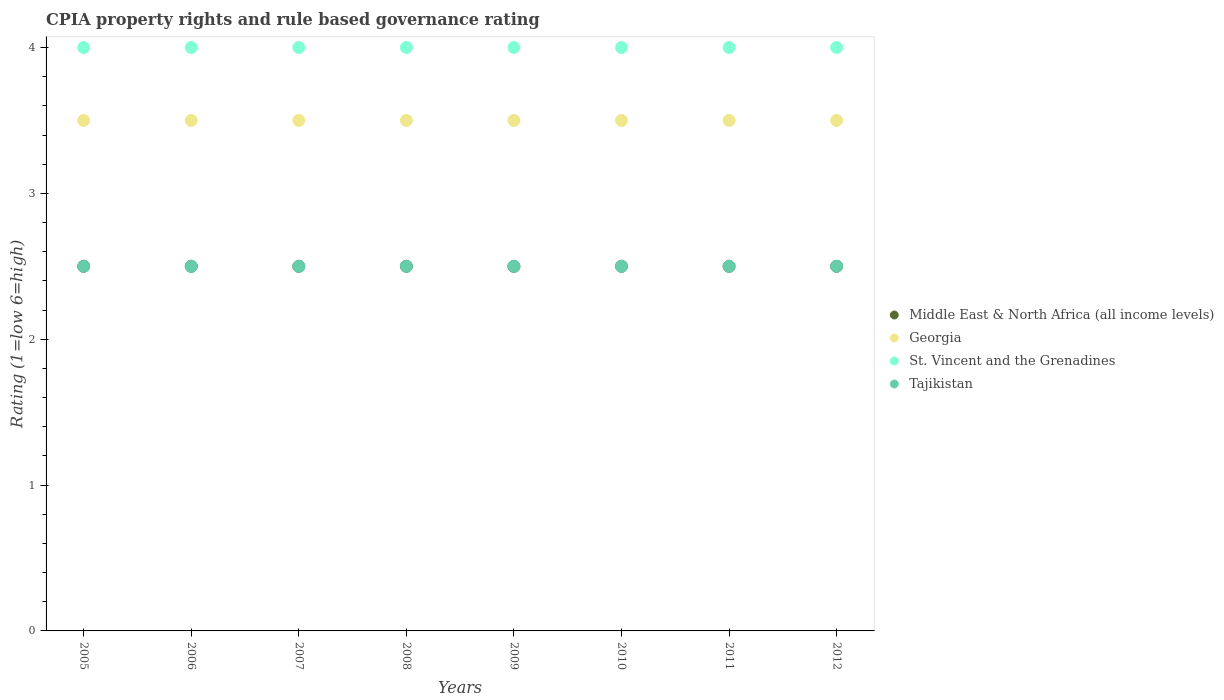Is the number of dotlines equal to the number of legend labels?
Your answer should be very brief. Yes. What is the CPIA rating in Middle East & North Africa (all income levels) in 2009?
Provide a succinct answer. 2.5. Across all years, what is the maximum CPIA rating in St. Vincent and the Grenadines?
Provide a short and direct response. 4. Across all years, what is the minimum CPIA rating in Tajikistan?
Ensure brevity in your answer.  2.5. In which year was the CPIA rating in St. Vincent and the Grenadines maximum?
Offer a terse response. 2005. In which year was the CPIA rating in Georgia minimum?
Your response must be concise. 2005. What is the difference between the CPIA rating in Middle East & North Africa (all income levels) in 2005 and that in 2009?
Provide a short and direct response. 0. What is the difference between the CPIA rating in Middle East & North Africa (all income levels) in 2006 and the CPIA rating in St. Vincent and the Grenadines in 2012?
Offer a terse response. -1.5. What is the average CPIA rating in Tajikistan per year?
Offer a very short reply. 2.5. In the year 2009, what is the difference between the CPIA rating in Middle East & North Africa (all income levels) and CPIA rating in St. Vincent and the Grenadines?
Your response must be concise. -1.5. In how many years, is the CPIA rating in Georgia greater than 3.6?
Your answer should be compact. 0. What is the ratio of the CPIA rating in St. Vincent and the Grenadines in 2005 to that in 2010?
Your answer should be very brief. 1. What is the difference between the highest and the second highest CPIA rating in St. Vincent and the Grenadines?
Give a very brief answer. 0. What is the difference between the highest and the lowest CPIA rating in Tajikistan?
Provide a succinct answer. 0. In how many years, is the CPIA rating in St. Vincent and the Grenadines greater than the average CPIA rating in St. Vincent and the Grenadines taken over all years?
Your answer should be very brief. 0. Is the CPIA rating in St. Vincent and the Grenadines strictly greater than the CPIA rating in Georgia over the years?
Ensure brevity in your answer.  Yes. Is the CPIA rating in Middle East & North Africa (all income levels) strictly less than the CPIA rating in St. Vincent and the Grenadines over the years?
Give a very brief answer. Yes. How many dotlines are there?
Provide a succinct answer. 4. What is the difference between two consecutive major ticks on the Y-axis?
Ensure brevity in your answer.  1. Does the graph contain grids?
Provide a succinct answer. No. Where does the legend appear in the graph?
Your response must be concise. Center right. How many legend labels are there?
Your response must be concise. 4. What is the title of the graph?
Make the answer very short. CPIA property rights and rule based governance rating. Does "Kyrgyz Republic" appear as one of the legend labels in the graph?
Provide a short and direct response. No. What is the label or title of the X-axis?
Offer a terse response. Years. What is the Rating (1=low 6=high) of St. Vincent and the Grenadines in 2005?
Provide a short and direct response. 4. What is the Rating (1=low 6=high) of Tajikistan in 2005?
Give a very brief answer. 2.5. What is the Rating (1=low 6=high) of Middle East & North Africa (all income levels) in 2006?
Offer a terse response. 2.5. What is the Rating (1=low 6=high) in St. Vincent and the Grenadines in 2006?
Offer a very short reply. 4. What is the Rating (1=low 6=high) in Tajikistan in 2006?
Offer a very short reply. 2.5. What is the Rating (1=low 6=high) of Georgia in 2007?
Give a very brief answer. 3.5. What is the Rating (1=low 6=high) in St. Vincent and the Grenadines in 2007?
Make the answer very short. 4. What is the Rating (1=low 6=high) of Georgia in 2008?
Ensure brevity in your answer.  3.5. What is the Rating (1=low 6=high) in Middle East & North Africa (all income levels) in 2010?
Your answer should be very brief. 2.5. What is the Rating (1=low 6=high) of Georgia in 2010?
Provide a succinct answer. 3.5. What is the Rating (1=low 6=high) in Middle East & North Africa (all income levels) in 2011?
Your answer should be compact. 2.5. What is the Rating (1=low 6=high) in Georgia in 2011?
Offer a very short reply. 3.5. What is the Rating (1=low 6=high) in Georgia in 2012?
Ensure brevity in your answer.  3.5. What is the Rating (1=low 6=high) of St. Vincent and the Grenadines in 2012?
Your response must be concise. 4. What is the Rating (1=low 6=high) of Tajikistan in 2012?
Provide a succinct answer. 2.5. Across all years, what is the maximum Rating (1=low 6=high) of Georgia?
Provide a short and direct response. 3.5. Across all years, what is the maximum Rating (1=low 6=high) of Tajikistan?
Make the answer very short. 2.5. Across all years, what is the minimum Rating (1=low 6=high) of St. Vincent and the Grenadines?
Ensure brevity in your answer.  4. What is the total Rating (1=low 6=high) in Middle East & North Africa (all income levels) in the graph?
Your response must be concise. 20. What is the total Rating (1=low 6=high) of Tajikistan in the graph?
Your answer should be very brief. 20. What is the difference between the Rating (1=low 6=high) of Georgia in 2005 and that in 2006?
Your response must be concise. 0. What is the difference between the Rating (1=low 6=high) of St. Vincent and the Grenadines in 2005 and that in 2006?
Provide a succinct answer. 0. What is the difference between the Rating (1=low 6=high) in Tajikistan in 2005 and that in 2006?
Offer a terse response. 0. What is the difference between the Rating (1=low 6=high) of Georgia in 2005 and that in 2007?
Give a very brief answer. 0. What is the difference between the Rating (1=low 6=high) of St. Vincent and the Grenadines in 2005 and that in 2007?
Your answer should be compact. 0. What is the difference between the Rating (1=low 6=high) of St. Vincent and the Grenadines in 2005 and that in 2008?
Provide a short and direct response. 0. What is the difference between the Rating (1=low 6=high) of Middle East & North Africa (all income levels) in 2005 and that in 2009?
Give a very brief answer. 0. What is the difference between the Rating (1=low 6=high) of Georgia in 2005 and that in 2009?
Offer a very short reply. 0. What is the difference between the Rating (1=low 6=high) in St. Vincent and the Grenadines in 2005 and that in 2010?
Provide a succinct answer. 0. What is the difference between the Rating (1=low 6=high) in Middle East & North Africa (all income levels) in 2005 and that in 2011?
Provide a succinct answer. 0. What is the difference between the Rating (1=low 6=high) in Georgia in 2005 and that in 2011?
Make the answer very short. 0. What is the difference between the Rating (1=low 6=high) of St. Vincent and the Grenadines in 2005 and that in 2011?
Offer a terse response. 0. What is the difference between the Rating (1=low 6=high) in Tajikistan in 2005 and that in 2011?
Your answer should be very brief. 0. What is the difference between the Rating (1=low 6=high) in Middle East & North Africa (all income levels) in 2005 and that in 2012?
Keep it short and to the point. 0. What is the difference between the Rating (1=low 6=high) in Georgia in 2005 and that in 2012?
Provide a succinct answer. 0. What is the difference between the Rating (1=low 6=high) of St. Vincent and the Grenadines in 2005 and that in 2012?
Your answer should be compact. 0. What is the difference between the Rating (1=low 6=high) of Tajikistan in 2005 and that in 2012?
Your answer should be very brief. 0. What is the difference between the Rating (1=low 6=high) in St. Vincent and the Grenadines in 2006 and that in 2007?
Your response must be concise. 0. What is the difference between the Rating (1=low 6=high) in Tajikistan in 2006 and that in 2007?
Your response must be concise. 0. What is the difference between the Rating (1=low 6=high) in Middle East & North Africa (all income levels) in 2006 and that in 2008?
Make the answer very short. 0. What is the difference between the Rating (1=low 6=high) of Georgia in 2006 and that in 2008?
Your answer should be compact. 0. What is the difference between the Rating (1=low 6=high) of St. Vincent and the Grenadines in 2006 and that in 2008?
Offer a very short reply. 0. What is the difference between the Rating (1=low 6=high) in Middle East & North Africa (all income levels) in 2006 and that in 2009?
Offer a terse response. 0. What is the difference between the Rating (1=low 6=high) of Georgia in 2006 and that in 2009?
Offer a terse response. 0. What is the difference between the Rating (1=low 6=high) of St. Vincent and the Grenadines in 2006 and that in 2009?
Offer a very short reply. 0. What is the difference between the Rating (1=low 6=high) in St. Vincent and the Grenadines in 2006 and that in 2010?
Your answer should be very brief. 0. What is the difference between the Rating (1=low 6=high) in Middle East & North Africa (all income levels) in 2006 and that in 2011?
Offer a terse response. 0. What is the difference between the Rating (1=low 6=high) of Georgia in 2006 and that in 2011?
Offer a terse response. 0. What is the difference between the Rating (1=low 6=high) of St. Vincent and the Grenadines in 2006 and that in 2011?
Your answer should be very brief. 0. What is the difference between the Rating (1=low 6=high) of Tajikistan in 2006 and that in 2011?
Ensure brevity in your answer.  0. What is the difference between the Rating (1=low 6=high) of St. Vincent and the Grenadines in 2006 and that in 2012?
Your answer should be compact. 0. What is the difference between the Rating (1=low 6=high) in Middle East & North Africa (all income levels) in 2007 and that in 2008?
Keep it short and to the point. 0. What is the difference between the Rating (1=low 6=high) of Georgia in 2007 and that in 2009?
Provide a succinct answer. 0. What is the difference between the Rating (1=low 6=high) of St. Vincent and the Grenadines in 2007 and that in 2009?
Provide a succinct answer. 0. What is the difference between the Rating (1=low 6=high) in Georgia in 2007 and that in 2010?
Offer a terse response. 0. What is the difference between the Rating (1=low 6=high) in Tajikistan in 2007 and that in 2010?
Offer a very short reply. 0. What is the difference between the Rating (1=low 6=high) of St. Vincent and the Grenadines in 2007 and that in 2011?
Give a very brief answer. 0. What is the difference between the Rating (1=low 6=high) of Georgia in 2007 and that in 2012?
Provide a short and direct response. 0. What is the difference between the Rating (1=low 6=high) of St. Vincent and the Grenadines in 2007 and that in 2012?
Ensure brevity in your answer.  0. What is the difference between the Rating (1=low 6=high) of St. Vincent and the Grenadines in 2008 and that in 2009?
Provide a short and direct response. 0. What is the difference between the Rating (1=low 6=high) of Middle East & North Africa (all income levels) in 2008 and that in 2010?
Your answer should be compact. 0. What is the difference between the Rating (1=low 6=high) of Georgia in 2008 and that in 2010?
Provide a short and direct response. 0. What is the difference between the Rating (1=low 6=high) of St. Vincent and the Grenadines in 2008 and that in 2010?
Your answer should be compact. 0. What is the difference between the Rating (1=low 6=high) of Middle East & North Africa (all income levels) in 2008 and that in 2011?
Your response must be concise. 0. What is the difference between the Rating (1=low 6=high) in Georgia in 2008 and that in 2011?
Your answer should be very brief. 0. What is the difference between the Rating (1=low 6=high) in St. Vincent and the Grenadines in 2008 and that in 2011?
Provide a short and direct response. 0. What is the difference between the Rating (1=low 6=high) in Tajikistan in 2008 and that in 2011?
Make the answer very short. 0. What is the difference between the Rating (1=low 6=high) of Georgia in 2008 and that in 2012?
Keep it short and to the point. 0. What is the difference between the Rating (1=low 6=high) in Tajikistan in 2008 and that in 2012?
Keep it short and to the point. 0. What is the difference between the Rating (1=low 6=high) in Middle East & North Africa (all income levels) in 2009 and that in 2010?
Give a very brief answer. 0. What is the difference between the Rating (1=low 6=high) in Georgia in 2009 and that in 2010?
Provide a succinct answer. 0. What is the difference between the Rating (1=low 6=high) in St. Vincent and the Grenadines in 2009 and that in 2010?
Keep it short and to the point. 0. What is the difference between the Rating (1=low 6=high) of St. Vincent and the Grenadines in 2009 and that in 2011?
Your answer should be very brief. 0. What is the difference between the Rating (1=low 6=high) of Middle East & North Africa (all income levels) in 2009 and that in 2012?
Ensure brevity in your answer.  0. What is the difference between the Rating (1=low 6=high) in Tajikistan in 2009 and that in 2012?
Your response must be concise. 0. What is the difference between the Rating (1=low 6=high) of Middle East & North Africa (all income levels) in 2010 and that in 2011?
Your answer should be very brief. 0. What is the difference between the Rating (1=low 6=high) in Georgia in 2010 and that in 2011?
Your answer should be compact. 0. What is the difference between the Rating (1=low 6=high) in Middle East & North Africa (all income levels) in 2010 and that in 2012?
Provide a short and direct response. 0. What is the difference between the Rating (1=low 6=high) in Georgia in 2010 and that in 2012?
Your answer should be very brief. 0. What is the difference between the Rating (1=low 6=high) in Middle East & North Africa (all income levels) in 2011 and that in 2012?
Ensure brevity in your answer.  0. What is the difference between the Rating (1=low 6=high) of Tajikistan in 2011 and that in 2012?
Your answer should be compact. 0. What is the difference between the Rating (1=low 6=high) of Middle East & North Africa (all income levels) in 2005 and the Rating (1=low 6=high) of St. Vincent and the Grenadines in 2006?
Keep it short and to the point. -1.5. What is the difference between the Rating (1=low 6=high) of Middle East & North Africa (all income levels) in 2005 and the Rating (1=low 6=high) of Tajikistan in 2006?
Provide a short and direct response. 0. What is the difference between the Rating (1=low 6=high) of Georgia in 2005 and the Rating (1=low 6=high) of St. Vincent and the Grenadines in 2006?
Provide a succinct answer. -0.5. What is the difference between the Rating (1=low 6=high) of St. Vincent and the Grenadines in 2005 and the Rating (1=low 6=high) of Tajikistan in 2006?
Your answer should be very brief. 1.5. What is the difference between the Rating (1=low 6=high) of Middle East & North Africa (all income levels) in 2005 and the Rating (1=low 6=high) of Georgia in 2007?
Your answer should be very brief. -1. What is the difference between the Rating (1=low 6=high) in Middle East & North Africa (all income levels) in 2005 and the Rating (1=low 6=high) in St. Vincent and the Grenadines in 2007?
Provide a short and direct response. -1.5. What is the difference between the Rating (1=low 6=high) in Middle East & North Africa (all income levels) in 2005 and the Rating (1=low 6=high) in Tajikistan in 2008?
Your response must be concise. 0. What is the difference between the Rating (1=low 6=high) of Georgia in 2005 and the Rating (1=low 6=high) of St. Vincent and the Grenadines in 2008?
Your answer should be very brief. -0.5. What is the difference between the Rating (1=low 6=high) of Middle East & North Africa (all income levels) in 2005 and the Rating (1=low 6=high) of Georgia in 2009?
Your response must be concise. -1. What is the difference between the Rating (1=low 6=high) of Middle East & North Africa (all income levels) in 2005 and the Rating (1=low 6=high) of St. Vincent and the Grenadines in 2009?
Your response must be concise. -1.5. What is the difference between the Rating (1=low 6=high) of Georgia in 2005 and the Rating (1=low 6=high) of Tajikistan in 2009?
Your response must be concise. 1. What is the difference between the Rating (1=low 6=high) of Middle East & North Africa (all income levels) in 2005 and the Rating (1=low 6=high) of Georgia in 2010?
Offer a terse response. -1. What is the difference between the Rating (1=low 6=high) of Georgia in 2005 and the Rating (1=low 6=high) of St. Vincent and the Grenadines in 2010?
Provide a succinct answer. -0.5. What is the difference between the Rating (1=low 6=high) in Georgia in 2005 and the Rating (1=low 6=high) in Tajikistan in 2010?
Keep it short and to the point. 1. What is the difference between the Rating (1=low 6=high) in St. Vincent and the Grenadines in 2005 and the Rating (1=low 6=high) in Tajikistan in 2010?
Offer a very short reply. 1.5. What is the difference between the Rating (1=low 6=high) of Middle East & North Africa (all income levels) in 2005 and the Rating (1=low 6=high) of Georgia in 2011?
Offer a very short reply. -1. What is the difference between the Rating (1=low 6=high) in Middle East & North Africa (all income levels) in 2005 and the Rating (1=low 6=high) in Tajikistan in 2011?
Your answer should be compact. 0. What is the difference between the Rating (1=low 6=high) in Georgia in 2005 and the Rating (1=low 6=high) in Tajikistan in 2011?
Your answer should be very brief. 1. What is the difference between the Rating (1=low 6=high) of Middle East & North Africa (all income levels) in 2005 and the Rating (1=low 6=high) of Georgia in 2012?
Make the answer very short. -1. What is the difference between the Rating (1=low 6=high) of Middle East & North Africa (all income levels) in 2005 and the Rating (1=low 6=high) of Tajikistan in 2012?
Provide a short and direct response. 0. What is the difference between the Rating (1=low 6=high) in Georgia in 2005 and the Rating (1=low 6=high) in St. Vincent and the Grenadines in 2012?
Keep it short and to the point. -0.5. What is the difference between the Rating (1=low 6=high) of St. Vincent and the Grenadines in 2005 and the Rating (1=low 6=high) of Tajikistan in 2012?
Ensure brevity in your answer.  1.5. What is the difference between the Rating (1=low 6=high) of Middle East & North Africa (all income levels) in 2006 and the Rating (1=low 6=high) of St. Vincent and the Grenadines in 2007?
Make the answer very short. -1.5. What is the difference between the Rating (1=low 6=high) of Georgia in 2006 and the Rating (1=low 6=high) of Tajikistan in 2007?
Ensure brevity in your answer.  1. What is the difference between the Rating (1=low 6=high) in St. Vincent and the Grenadines in 2006 and the Rating (1=low 6=high) in Tajikistan in 2007?
Keep it short and to the point. 1.5. What is the difference between the Rating (1=low 6=high) of Middle East & North Africa (all income levels) in 2006 and the Rating (1=low 6=high) of St. Vincent and the Grenadines in 2008?
Keep it short and to the point. -1.5. What is the difference between the Rating (1=low 6=high) in Georgia in 2006 and the Rating (1=low 6=high) in St. Vincent and the Grenadines in 2008?
Provide a succinct answer. -0.5. What is the difference between the Rating (1=low 6=high) of Georgia in 2006 and the Rating (1=low 6=high) of St. Vincent and the Grenadines in 2009?
Make the answer very short. -0.5. What is the difference between the Rating (1=low 6=high) of Middle East & North Africa (all income levels) in 2006 and the Rating (1=low 6=high) of Georgia in 2010?
Keep it short and to the point. -1. What is the difference between the Rating (1=low 6=high) in Middle East & North Africa (all income levels) in 2006 and the Rating (1=low 6=high) in Tajikistan in 2011?
Offer a terse response. 0. What is the difference between the Rating (1=low 6=high) in Georgia in 2006 and the Rating (1=low 6=high) in St. Vincent and the Grenadines in 2011?
Offer a very short reply. -0.5. What is the difference between the Rating (1=low 6=high) in Middle East & North Africa (all income levels) in 2006 and the Rating (1=low 6=high) in Georgia in 2012?
Your answer should be very brief. -1. What is the difference between the Rating (1=low 6=high) in Georgia in 2006 and the Rating (1=low 6=high) in St. Vincent and the Grenadines in 2012?
Keep it short and to the point. -0.5. What is the difference between the Rating (1=low 6=high) of Georgia in 2006 and the Rating (1=low 6=high) of Tajikistan in 2012?
Your response must be concise. 1. What is the difference between the Rating (1=low 6=high) of St. Vincent and the Grenadines in 2006 and the Rating (1=low 6=high) of Tajikistan in 2012?
Keep it short and to the point. 1.5. What is the difference between the Rating (1=low 6=high) of Middle East & North Africa (all income levels) in 2007 and the Rating (1=low 6=high) of Georgia in 2008?
Offer a terse response. -1. What is the difference between the Rating (1=low 6=high) in Middle East & North Africa (all income levels) in 2007 and the Rating (1=low 6=high) in St. Vincent and the Grenadines in 2008?
Provide a succinct answer. -1.5. What is the difference between the Rating (1=low 6=high) in Middle East & North Africa (all income levels) in 2007 and the Rating (1=low 6=high) in Tajikistan in 2008?
Your answer should be very brief. 0. What is the difference between the Rating (1=low 6=high) of Georgia in 2007 and the Rating (1=low 6=high) of St. Vincent and the Grenadines in 2008?
Give a very brief answer. -0.5. What is the difference between the Rating (1=low 6=high) in St. Vincent and the Grenadines in 2007 and the Rating (1=low 6=high) in Tajikistan in 2008?
Provide a succinct answer. 1.5. What is the difference between the Rating (1=low 6=high) in Middle East & North Africa (all income levels) in 2007 and the Rating (1=low 6=high) in Georgia in 2009?
Keep it short and to the point. -1. What is the difference between the Rating (1=low 6=high) in Middle East & North Africa (all income levels) in 2007 and the Rating (1=low 6=high) in St. Vincent and the Grenadines in 2009?
Offer a very short reply. -1.5. What is the difference between the Rating (1=low 6=high) in Georgia in 2007 and the Rating (1=low 6=high) in Tajikistan in 2009?
Provide a short and direct response. 1. What is the difference between the Rating (1=low 6=high) of Middle East & North Africa (all income levels) in 2007 and the Rating (1=low 6=high) of St. Vincent and the Grenadines in 2010?
Offer a very short reply. -1.5. What is the difference between the Rating (1=low 6=high) of Middle East & North Africa (all income levels) in 2007 and the Rating (1=low 6=high) of Tajikistan in 2010?
Provide a succinct answer. 0. What is the difference between the Rating (1=low 6=high) of St. Vincent and the Grenadines in 2007 and the Rating (1=low 6=high) of Tajikistan in 2010?
Make the answer very short. 1.5. What is the difference between the Rating (1=low 6=high) of Middle East & North Africa (all income levels) in 2007 and the Rating (1=low 6=high) of Georgia in 2011?
Provide a short and direct response. -1. What is the difference between the Rating (1=low 6=high) in Middle East & North Africa (all income levels) in 2007 and the Rating (1=low 6=high) in Tajikistan in 2011?
Provide a succinct answer. 0. What is the difference between the Rating (1=low 6=high) of St. Vincent and the Grenadines in 2007 and the Rating (1=low 6=high) of Tajikistan in 2011?
Your response must be concise. 1.5. What is the difference between the Rating (1=low 6=high) of Middle East & North Africa (all income levels) in 2007 and the Rating (1=low 6=high) of Georgia in 2012?
Offer a very short reply. -1. What is the difference between the Rating (1=low 6=high) of Georgia in 2007 and the Rating (1=low 6=high) of Tajikistan in 2012?
Ensure brevity in your answer.  1. What is the difference between the Rating (1=low 6=high) of St. Vincent and the Grenadines in 2007 and the Rating (1=low 6=high) of Tajikistan in 2012?
Keep it short and to the point. 1.5. What is the difference between the Rating (1=low 6=high) in Middle East & North Africa (all income levels) in 2008 and the Rating (1=low 6=high) in Georgia in 2009?
Provide a short and direct response. -1. What is the difference between the Rating (1=low 6=high) of Middle East & North Africa (all income levels) in 2008 and the Rating (1=low 6=high) of St. Vincent and the Grenadines in 2010?
Provide a short and direct response. -1.5. What is the difference between the Rating (1=low 6=high) of Middle East & North Africa (all income levels) in 2008 and the Rating (1=low 6=high) of Tajikistan in 2010?
Ensure brevity in your answer.  0. What is the difference between the Rating (1=low 6=high) of Georgia in 2008 and the Rating (1=low 6=high) of St. Vincent and the Grenadines in 2010?
Provide a succinct answer. -0.5. What is the difference between the Rating (1=low 6=high) in St. Vincent and the Grenadines in 2008 and the Rating (1=low 6=high) in Tajikistan in 2010?
Your answer should be compact. 1.5. What is the difference between the Rating (1=low 6=high) of Middle East & North Africa (all income levels) in 2008 and the Rating (1=low 6=high) of St. Vincent and the Grenadines in 2011?
Ensure brevity in your answer.  -1.5. What is the difference between the Rating (1=low 6=high) of Georgia in 2008 and the Rating (1=low 6=high) of St. Vincent and the Grenadines in 2011?
Ensure brevity in your answer.  -0.5. What is the difference between the Rating (1=low 6=high) in Georgia in 2008 and the Rating (1=low 6=high) in Tajikistan in 2011?
Make the answer very short. 1. What is the difference between the Rating (1=low 6=high) of Middle East & North Africa (all income levels) in 2008 and the Rating (1=low 6=high) of Georgia in 2012?
Your response must be concise. -1. What is the difference between the Rating (1=low 6=high) in Georgia in 2008 and the Rating (1=low 6=high) in St. Vincent and the Grenadines in 2012?
Keep it short and to the point. -0.5. What is the difference between the Rating (1=low 6=high) in Georgia in 2008 and the Rating (1=low 6=high) in Tajikistan in 2012?
Give a very brief answer. 1. What is the difference between the Rating (1=low 6=high) in St. Vincent and the Grenadines in 2008 and the Rating (1=low 6=high) in Tajikistan in 2012?
Provide a succinct answer. 1.5. What is the difference between the Rating (1=low 6=high) of Middle East & North Africa (all income levels) in 2009 and the Rating (1=low 6=high) of Tajikistan in 2010?
Give a very brief answer. 0. What is the difference between the Rating (1=low 6=high) in Georgia in 2009 and the Rating (1=low 6=high) in Tajikistan in 2010?
Your answer should be compact. 1. What is the difference between the Rating (1=low 6=high) of Middle East & North Africa (all income levels) in 2009 and the Rating (1=low 6=high) of Georgia in 2011?
Offer a very short reply. -1. What is the difference between the Rating (1=low 6=high) of Middle East & North Africa (all income levels) in 2009 and the Rating (1=low 6=high) of Tajikistan in 2011?
Your answer should be compact. 0. What is the difference between the Rating (1=low 6=high) in Georgia in 2009 and the Rating (1=low 6=high) in St. Vincent and the Grenadines in 2011?
Provide a succinct answer. -0.5. What is the difference between the Rating (1=low 6=high) in Georgia in 2009 and the Rating (1=low 6=high) in Tajikistan in 2011?
Provide a succinct answer. 1. What is the difference between the Rating (1=low 6=high) of Middle East & North Africa (all income levels) in 2009 and the Rating (1=low 6=high) of St. Vincent and the Grenadines in 2012?
Your answer should be very brief. -1.5. What is the difference between the Rating (1=low 6=high) in Georgia in 2009 and the Rating (1=low 6=high) in St. Vincent and the Grenadines in 2012?
Your response must be concise. -0.5. What is the difference between the Rating (1=low 6=high) of Georgia in 2009 and the Rating (1=low 6=high) of Tajikistan in 2012?
Give a very brief answer. 1. What is the difference between the Rating (1=low 6=high) of St. Vincent and the Grenadines in 2009 and the Rating (1=low 6=high) of Tajikistan in 2012?
Offer a very short reply. 1.5. What is the difference between the Rating (1=low 6=high) in Middle East & North Africa (all income levels) in 2010 and the Rating (1=low 6=high) in Georgia in 2011?
Provide a succinct answer. -1. What is the difference between the Rating (1=low 6=high) in Middle East & North Africa (all income levels) in 2010 and the Rating (1=low 6=high) in Tajikistan in 2011?
Your answer should be compact. 0. What is the difference between the Rating (1=low 6=high) of Georgia in 2010 and the Rating (1=low 6=high) of Tajikistan in 2011?
Provide a short and direct response. 1. What is the difference between the Rating (1=low 6=high) in St. Vincent and the Grenadines in 2010 and the Rating (1=low 6=high) in Tajikistan in 2011?
Your answer should be compact. 1.5. What is the difference between the Rating (1=low 6=high) in Middle East & North Africa (all income levels) in 2010 and the Rating (1=low 6=high) in Tajikistan in 2012?
Offer a terse response. 0. What is the difference between the Rating (1=low 6=high) of Georgia in 2010 and the Rating (1=low 6=high) of St. Vincent and the Grenadines in 2012?
Your response must be concise. -0.5. What is the difference between the Rating (1=low 6=high) in St. Vincent and the Grenadines in 2010 and the Rating (1=low 6=high) in Tajikistan in 2012?
Provide a short and direct response. 1.5. What is the difference between the Rating (1=low 6=high) of Middle East & North Africa (all income levels) in 2011 and the Rating (1=low 6=high) of St. Vincent and the Grenadines in 2012?
Ensure brevity in your answer.  -1.5. What is the difference between the Rating (1=low 6=high) of Middle East & North Africa (all income levels) in 2011 and the Rating (1=low 6=high) of Tajikistan in 2012?
Provide a short and direct response. 0. What is the difference between the Rating (1=low 6=high) of Georgia in 2011 and the Rating (1=low 6=high) of St. Vincent and the Grenadines in 2012?
Give a very brief answer. -0.5. What is the average Rating (1=low 6=high) of Middle East & North Africa (all income levels) per year?
Offer a terse response. 2.5. What is the average Rating (1=low 6=high) of Georgia per year?
Provide a succinct answer. 3.5. What is the average Rating (1=low 6=high) in St. Vincent and the Grenadines per year?
Provide a short and direct response. 4. What is the average Rating (1=low 6=high) in Tajikistan per year?
Provide a succinct answer. 2.5. In the year 2005, what is the difference between the Rating (1=low 6=high) in Middle East & North Africa (all income levels) and Rating (1=low 6=high) in Georgia?
Ensure brevity in your answer.  -1. In the year 2005, what is the difference between the Rating (1=low 6=high) of Middle East & North Africa (all income levels) and Rating (1=low 6=high) of St. Vincent and the Grenadines?
Give a very brief answer. -1.5. In the year 2005, what is the difference between the Rating (1=low 6=high) of Georgia and Rating (1=low 6=high) of St. Vincent and the Grenadines?
Provide a succinct answer. -0.5. In the year 2005, what is the difference between the Rating (1=low 6=high) of Georgia and Rating (1=low 6=high) of Tajikistan?
Keep it short and to the point. 1. In the year 2006, what is the difference between the Rating (1=low 6=high) of Middle East & North Africa (all income levels) and Rating (1=low 6=high) of Tajikistan?
Provide a short and direct response. 0. In the year 2007, what is the difference between the Rating (1=low 6=high) in Middle East & North Africa (all income levels) and Rating (1=low 6=high) in Georgia?
Offer a terse response. -1. In the year 2007, what is the difference between the Rating (1=low 6=high) in Middle East & North Africa (all income levels) and Rating (1=low 6=high) in St. Vincent and the Grenadines?
Your answer should be very brief. -1.5. In the year 2007, what is the difference between the Rating (1=low 6=high) in Middle East & North Africa (all income levels) and Rating (1=low 6=high) in Tajikistan?
Keep it short and to the point. 0. In the year 2007, what is the difference between the Rating (1=low 6=high) of Georgia and Rating (1=low 6=high) of St. Vincent and the Grenadines?
Give a very brief answer. -0.5. In the year 2007, what is the difference between the Rating (1=low 6=high) in St. Vincent and the Grenadines and Rating (1=low 6=high) in Tajikistan?
Your answer should be very brief. 1.5. In the year 2008, what is the difference between the Rating (1=low 6=high) of Middle East & North Africa (all income levels) and Rating (1=low 6=high) of St. Vincent and the Grenadines?
Give a very brief answer. -1.5. In the year 2008, what is the difference between the Rating (1=low 6=high) in Middle East & North Africa (all income levels) and Rating (1=low 6=high) in Tajikistan?
Offer a terse response. 0. In the year 2008, what is the difference between the Rating (1=low 6=high) of Georgia and Rating (1=low 6=high) of Tajikistan?
Offer a terse response. 1. In the year 2009, what is the difference between the Rating (1=low 6=high) in Middle East & North Africa (all income levels) and Rating (1=low 6=high) in Georgia?
Provide a succinct answer. -1. In the year 2009, what is the difference between the Rating (1=low 6=high) of Middle East & North Africa (all income levels) and Rating (1=low 6=high) of St. Vincent and the Grenadines?
Provide a short and direct response. -1.5. In the year 2009, what is the difference between the Rating (1=low 6=high) in Georgia and Rating (1=low 6=high) in St. Vincent and the Grenadines?
Provide a succinct answer. -0.5. In the year 2009, what is the difference between the Rating (1=low 6=high) of Georgia and Rating (1=low 6=high) of Tajikistan?
Your answer should be very brief. 1. In the year 2009, what is the difference between the Rating (1=low 6=high) of St. Vincent and the Grenadines and Rating (1=low 6=high) of Tajikistan?
Provide a succinct answer. 1.5. In the year 2010, what is the difference between the Rating (1=low 6=high) of Middle East & North Africa (all income levels) and Rating (1=low 6=high) of Tajikistan?
Keep it short and to the point. 0. In the year 2010, what is the difference between the Rating (1=low 6=high) in Georgia and Rating (1=low 6=high) in St. Vincent and the Grenadines?
Make the answer very short. -0.5. In the year 2010, what is the difference between the Rating (1=low 6=high) in Georgia and Rating (1=low 6=high) in Tajikistan?
Your answer should be very brief. 1. In the year 2010, what is the difference between the Rating (1=low 6=high) in St. Vincent and the Grenadines and Rating (1=low 6=high) in Tajikistan?
Provide a succinct answer. 1.5. In the year 2011, what is the difference between the Rating (1=low 6=high) of Middle East & North Africa (all income levels) and Rating (1=low 6=high) of Georgia?
Provide a short and direct response. -1. In the year 2011, what is the difference between the Rating (1=low 6=high) of Middle East & North Africa (all income levels) and Rating (1=low 6=high) of Tajikistan?
Give a very brief answer. 0. In the year 2011, what is the difference between the Rating (1=low 6=high) in Georgia and Rating (1=low 6=high) in St. Vincent and the Grenadines?
Give a very brief answer. -0.5. In the year 2011, what is the difference between the Rating (1=low 6=high) in St. Vincent and the Grenadines and Rating (1=low 6=high) in Tajikistan?
Your answer should be compact. 1.5. What is the ratio of the Rating (1=low 6=high) of Georgia in 2005 to that in 2006?
Provide a short and direct response. 1. What is the ratio of the Rating (1=low 6=high) in St. Vincent and the Grenadines in 2005 to that in 2007?
Offer a terse response. 1. What is the ratio of the Rating (1=low 6=high) of Tajikistan in 2005 to that in 2007?
Offer a terse response. 1. What is the ratio of the Rating (1=low 6=high) of Georgia in 2005 to that in 2008?
Provide a succinct answer. 1. What is the ratio of the Rating (1=low 6=high) of Middle East & North Africa (all income levels) in 2005 to that in 2009?
Your answer should be very brief. 1. What is the ratio of the Rating (1=low 6=high) in Georgia in 2005 to that in 2009?
Your answer should be very brief. 1. What is the ratio of the Rating (1=low 6=high) of Tajikistan in 2005 to that in 2009?
Your response must be concise. 1. What is the ratio of the Rating (1=low 6=high) of Middle East & North Africa (all income levels) in 2005 to that in 2010?
Make the answer very short. 1. What is the ratio of the Rating (1=low 6=high) of Georgia in 2005 to that in 2010?
Provide a succinct answer. 1. What is the ratio of the Rating (1=low 6=high) of Middle East & North Africa (all income levels) in 2005 to that in 2011?
Your response must be concise. 1. What is the ratio of the Rating (1=low 6=high) in St. Vincent and the Grenadines in 2005 to that in 2011?
Your answer should be compact. 1. What is the ratio of the Rating (1=low 6=high) of Middle East & North Africa (all income levels) in 2005 to that in 2012?
Your answer should be compact. 1. What is the ratio of the Rating (1=low 6=high) of Georgia in 2005 to that in 2012?
Offer a terse response. 1. What is the ratio of the Rating (1=low 6=high) of St. Vincent and the Grenadines in 2005 to that in 2012?
Provide a short and direct response. 1. What is the ratio of the Rating (1=low 6=high) of Middle East & North Africa (all income levels) in 2006 to that in 2007?
Keep it short and to the point. 1. What is the ratio of the Rating (1=low 6=high) of Tajikistan in 2006 to that in 2007?
Keep it short and to the point. 1. What is the ratio of the Rating (1=low 6=high) of St. Vincent and the Grenadines in 2006 to that in 2008?
Offer a terse response. 1. What is the ratio of the Rating (1=low 6=high) in Tajikistan in 2006 to that in 2008?
Your response must be concise. 1. What is the ratio of the Rating (1=low 6=high) in St. Vincent and the Grenadines in 2006 to that in 2009?
Make the answer very short. 1. What is the ratio of the Rating (1=low 6=high) in Tajikistan in 2006 to that in 2009?
Provide a succinct answer. 1. What is the ratio of the Rating (1=low 6=high) in Middle East & North Africa (all income levels) in 2006 to that in 2010?
Offer a terse response. 1. What is the ratio of the Rating (1=low 6=high) in St. Vincent and the Grenadines in 2006 to that in 2010?
Keep it short and to the point. 1. What is the ratio of the Rating (1=low 6=high) in St. Vincent and the Grenadines in 2006 to that in 2011?
Give a very brief answer. 1. What is the ratio of the Rating (1=low 6=high) of Georgia in 2006 to that in 2012?
Keep it short and to the point. 1. What is the ratio of the Rating (1=low 6=high) of St. Vincent and the Grenadines in 2006 to that in 2012?
Your answer should be very brief. 1. What is the ratio of the Rating (1=low 6=high) in Tajikistan in 2006 to that in 2012?
Your answer should be compact. 1. What is the ratio of the Rating (1=low 6=high) of Middle East & North Africa (all income levels) in 2007 to that in 2008?
Make the answer very short. 1. What is the ratio of the Rating (1=low 6=high) of St. Vincent and the Grenadines in 2007 to that in 2008?
Make the answer very short. 1. What is the ratio of the Rating (1=low 6=high) of Georgia in 2007 to that in 2009?
Your answer should be compact. 1. What is the ratio of the Rating (1=low 6=high) in St. Vincent and the Grenadines in 2007 to that in 2009?
Offer a very short reply. 1. What is the ratio of the Rating (1=low 6=high) in Middle East & North Africa (all income levels) in 2007 to that in 2010?
Make the answer very short. 1. What is the ratio of the Rating (1=low 6=high) in Middle East & North Africa (all income levels) in 2007 to that in 2011?
Make the answer very short. 1. What is the ratio of the Rating (1=low 6=high) in Georgia in 2007 to that in 2011?
Offer a very short reply. 1. What is the ratio of the Rating (1=low 6=high) in Georgia in 2007 to that in 2012?
Offer a very short reply. 1. What is the ratio of the Rating (1=low 6=high) of St. Vincent and the Grenadines in 2007 to that in 2012?
Ensure brevity in your answer.  1. What is the ratio of the Rating (1=low 6=high) in Tajikistan in 2007 to that in 2012?
Keep it short and to the point. 1. What is the ratio of the Rating (1=low 6=high) in Middle East & North Africa (all income levels) in 2008 to that in 2010?
Keep it short and to the point. 1. What is the ratio of the Rating (1=low 6=high) of St. Vincent and the Grenadines in 2008 to that in 2010?
Give a very brief answer. 1. What is the ratio of the Rating (1=low 6=high) of Tajikistan in 2008 to that in 2010?
Provide a short and direct response. 1. What is the ratio of the Rating (1=low 6=high) of Georgia in 2008 to that in 2011?
Make the answer very short. 1. What is the ratio of the Rating (1=low 6=high) of Tajikistan in 2008 to that in 2011?
Offer a terse response. 1. What is the ratio of the Rating (1=low 6=high) in Middle East & North Africa (all income levels) in 2008 to that in 2012?
Keep it short and to the point. 1. What is the ratio of the Rating (1=low 6=high) of St. Vincent and the Grenadines in 2008 to that in 2012?
Offer a very short reply. 1. What is the ratio of the Rating (1=low 6=high) of Middle East & North Africa (all income levels) in 2009 to that in 2010?
Keep it short and to the point. 1. What is the ratio of the Rating (1=low 6=high) of St. Vincent and the Grenadines in 2009 to that in 2010?
Provide a succinct answer. 1. What is the ratio of the Rating (1=low 6=high) of Georgia in 2009 to that in 2011?
Provide a short and direct response. 1. What is the ratio of the Rating (1=low 6=high) in Middle East & North Africa (all income levels) in 2010 to that in 2011?
Your response must be concise. 1. What is the ratio of the Rating (1=low 6=high) in Georgia in 2010 to that in 2011?
Give a very brief answer. 1. What is the ratio of the Rating (1=low 6=high) in Tajikistan in 2010 to that in 2011?
Your answer should be compact. 1. What is the ratio of the Rating (1=low 6=high) in Middle East & North Africa (all income levels) in 2010 to that in 2012?
Your answer should be compact. 1. What is the ratio of the Rating (1=low 6=high) in Georgia in 2010 to that in 2012?
Give a very brief answer. 1. What is the ratio of the Rating (1=low 6=high) in St. Vincent and the Grenadines in 2011 to that in 2012?
Your answer should be very brief. 1. What is the difference between the highest and the second highest Rating (1=low 6=high) of St. Vincent and the Grenadines?
Offer a terse response. 0. What is the difference between the highest and the second highest Rating (1=low 6=high) in Tajikistan?
Give a very brief answer. 0. What is the difference between the highest and the lowest Rating (1=low 6=high) of Middle East & North Africa (all income levels)?
Your answer should be very brief. 0. What is the difference between the highest and the lowest Rating (1=low 6=high) of St. Vincent and the Grenadines?
Your response must be concise. 0. 